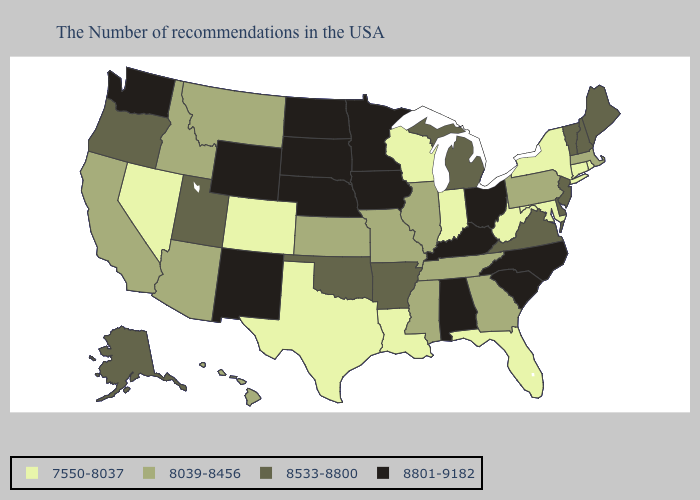Name the states that have a value in the range 7550-8037?
Write a very short answer. Rhode Island, Connecticut, New York, Maryland, West Virginia, Florida, Indiana, Wisconsin, Louisiana, Texas, Colorado, Nevada. Does North Carolina have the lowest value in the USA?
Be succinct. No. Among the states that border Oklahoma , which have the highest value?
Concise answer only. New Mexico. Does the map have missing data?
Short answer required. No. Which states have the lowest value in the USA?
Answer briefly. Rhode Island, Connecticut, New York, Maryland, West Virginia, Florida, Indiana, Wisconsin, Louisiana, Texas, Colorado, Nevada. Does the map have missing data?
Answer briefly. No. Name the states that have a value in the range 8533-8800?
Keep it brief. Maine, New Hampshire, Vermont, New Jersey, Delaware, Virginia, Michigan, Arkansas, Oklahoma, Utah, Oregon, Alaska. Name the states that have a value in the range 8801-9182?
Write a very short answer. North Carolina, South Carolina, Ohio, Kentucky, Alabama, Minnesota, Iowa, Nebraska, South Dakota, North Dakota, Wyoming, New Mexico, Washington. What is the value of New Mexico?
Be succinct. 8801-9182. What is the lowest value in the USA?
Give a very brief answer. 7550-8037. Which states have the highest value in the USA?
Concise answer only. North Carolina, South Carolina, Ohio, Kentucky, Alabama, Minnesota, Iowa, Nebraska, South Dakota, North Dakota, Wyoming, New Mexico, Washington. Name the states that have a value in the range 7550-8037?
Quick response, please. Rhode Island, Connecticut, New York, Maryland, West Virginia, Florida, Indiana, Wisconsin, Louisiana, Texas, Colorado, Nevada. Name the states that have a value in the range 7550-8037?
Answer briefly. Rhode Island, Connecticut, New York, Maryland, West Virginia, Florida, Indiana, Wisconsin, Louisiana, Texas, Colorado, Nevada. What is the lowest value in the Northeast?
Keep it brief. 7550-8037. Which states have the highest value in the USA?
Write a very short answer. North Carolina, South Carolina, Ohio, Kentucky, Alabama, Minnesota, Iowa, Nebraska, South Dakota, North Dakota, Wyoming, New Mexico, Washington. 